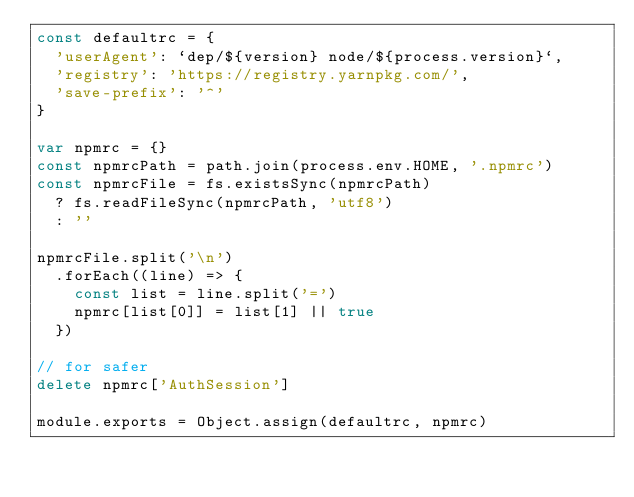Convert code to text. <code><loc_0><loc_0><loc_500><loc_500><_JavaScript_>const defaultrc = {
  'userAgent': `dep/${version} node/${process.version}`,
  'registry': 'https://registry.yarnpkg.com/',
  'save-prefix': '^'
}

var npmrc = {}
const npmrcPath = path.join(process.env.HOME, '.npmrc')
const npmrcFile = fs.existsSync(npmrcPath)
  ? fs.readFileSync(npmrcPath, 'utf8')
  : ''

npmrcFile.split('\n')
  .forEach((line) => {
    const list = line.split('=')
    npmrc[list[0]] = list[1] || true
  })

// for safer
delete npmrc['AuthSession']

module.exports = Object.assign(defaultrc, npmrc)
</code> 